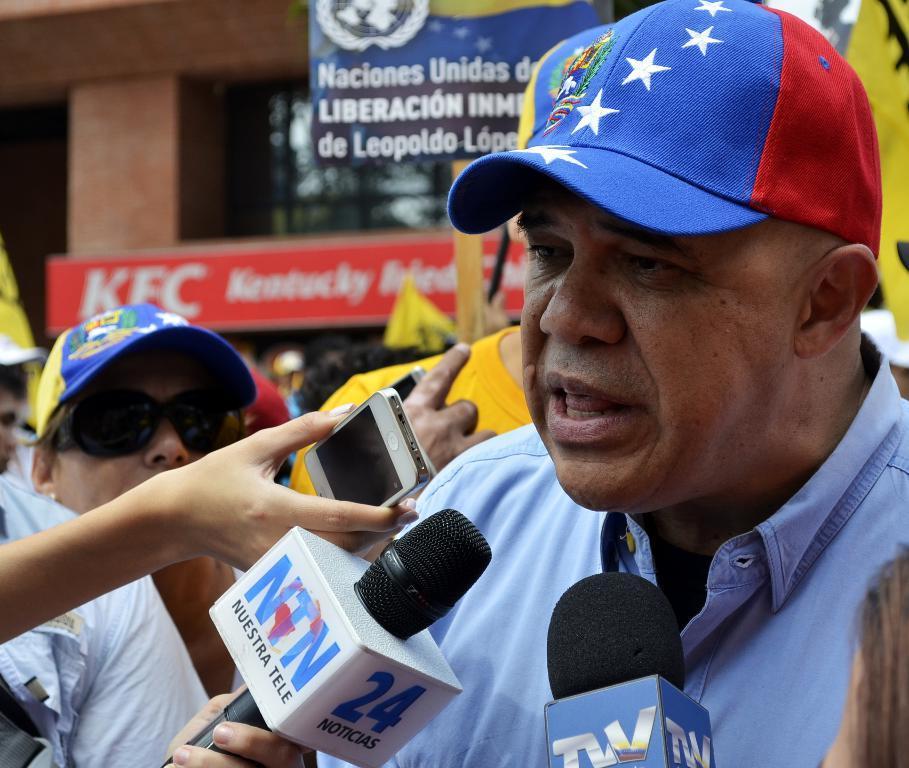How would you summarize this image in a sentence or two? Bottom left side of the image there are some microphones and there are some hands. In the hands there are some electronic devices. Bottom right side of the image a man is standing. Behind him few people are standing. Top left side of the image there is a building, on the building there are some banners. 